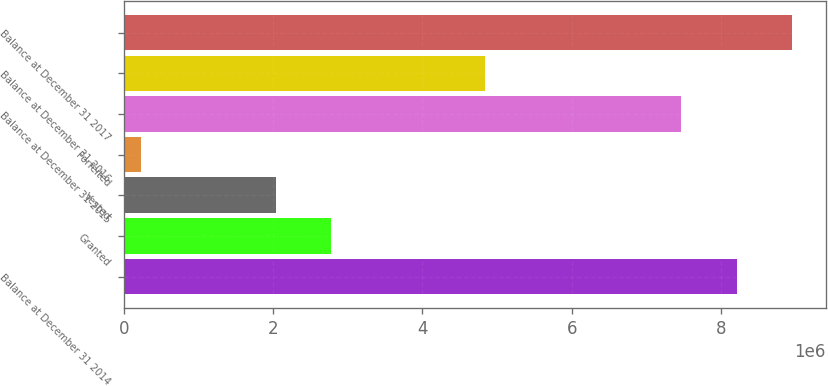<chart> <loc_0><loc_0><loc_500><loc_500><bar_chart><fcel>Balance at December 31 2014<fcel>Granted<fcel>Vested<fcel>Forfeited<fcel>Balance at December 31 2015<fcel>Balance at December 31 2016<fcel>Balance at December 31 2017<nl><fcel>8.21103e+06<fcel>2.77723e+06<fcel>2.03326e+06<fcel>237406<fcel>7.46706e+06<fcel>4.84327e+06<fcel>8.955e+06<nl></chart> 